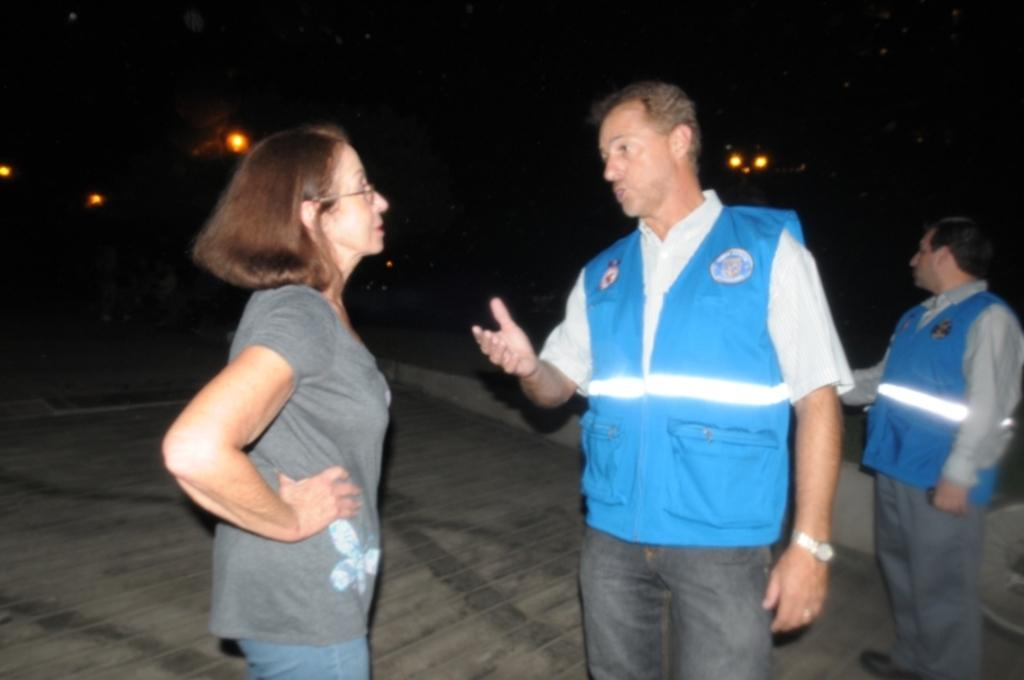How many people are in the image? There are three persons standing in the image. What can be observed about the background of the image? The background of the image is dark. Are there any additional features visible in the background? Yes, there are lights visible in the background of the image. What type of slope can be seen in the image? There is no slope present in the image; it features three persons standing against a dark background with visible lights. 